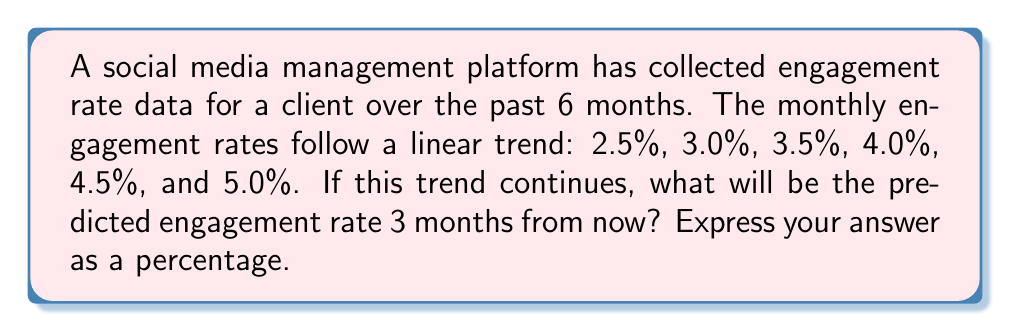Can you answer this question? To solve this problem, we need to follow these steps:

1. Identify the linear pattern in the given data:
   The engagement rate increases by 0.5% each month.

2. Set up a linear equation:
   Let $y$ be the engagement rate and $x$ be the number of months.
   The equation is of the form $y = mx + b$, where $m$ is the slope and $b$ is the y-intercept.

3. Calculate the slope $m$:
   $m = \frac{\text{change in y}}{\text{change in x}} = \frac{0.5\%}{1\text{ month}} = 0.5\%\text{ per month}$

4. Find the y-intercept $b$:
   Using the first data point (month 0, 2.5%):
   $2.5\% = 0.5\% \cdot 0 + b$
   $b = 2.5\%$

5. Write the complete linear equation:
   $y = 0.5\%x + 2.5\%$

6. Predict the engagement rate 3 months from now:
   The last given data point is for month 5, so we need to calculate for month 8.
   $y = 0.5\% \cdot 8 + 2.5\%$
   $y = 4\% + 2.5\%$
   $y = 6.5\%$

Therefore, the predicted engagement rate 3 months from now is 6.5%.
Answer: 6.5% 